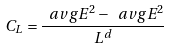Convert formula to latex. <formula><loc_0><loc_0><loc_500><loc_500>C _ { L } = \frac { \ a v g { E ^ { 2 } } - \ a v g { E } ^ { 2 } } { L ^ { d } }</formula> 